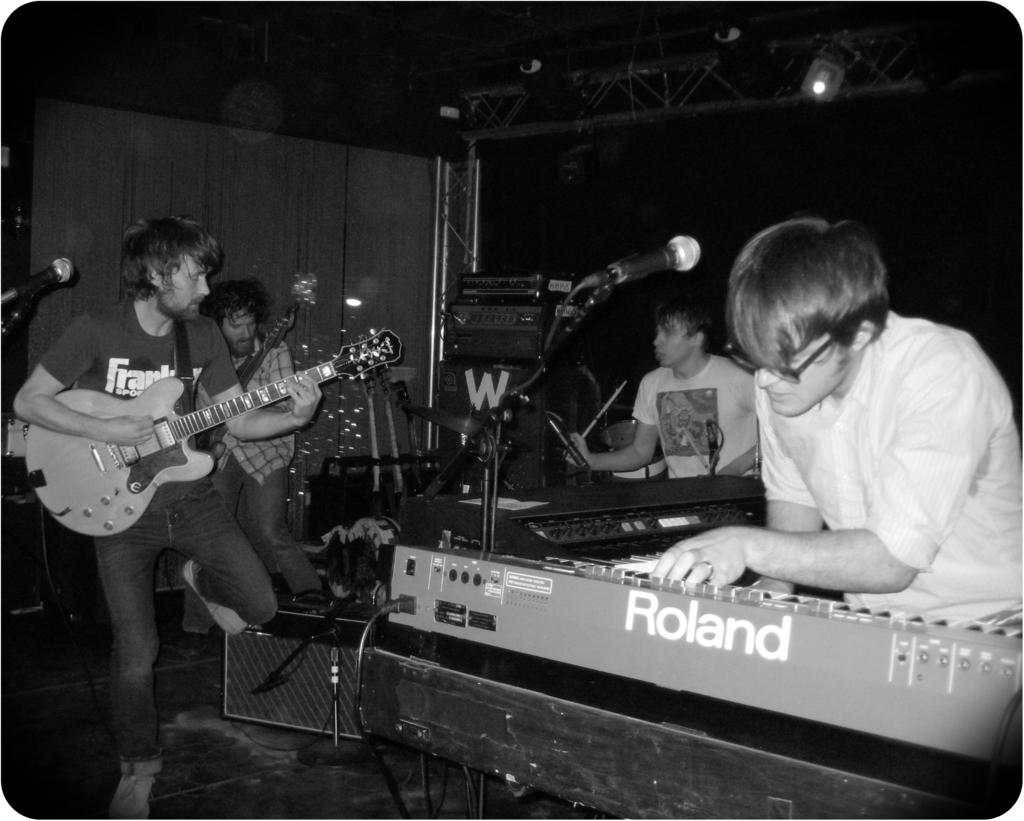What brand is the keyboard piano?
Provide a short and direct response. Roland. 